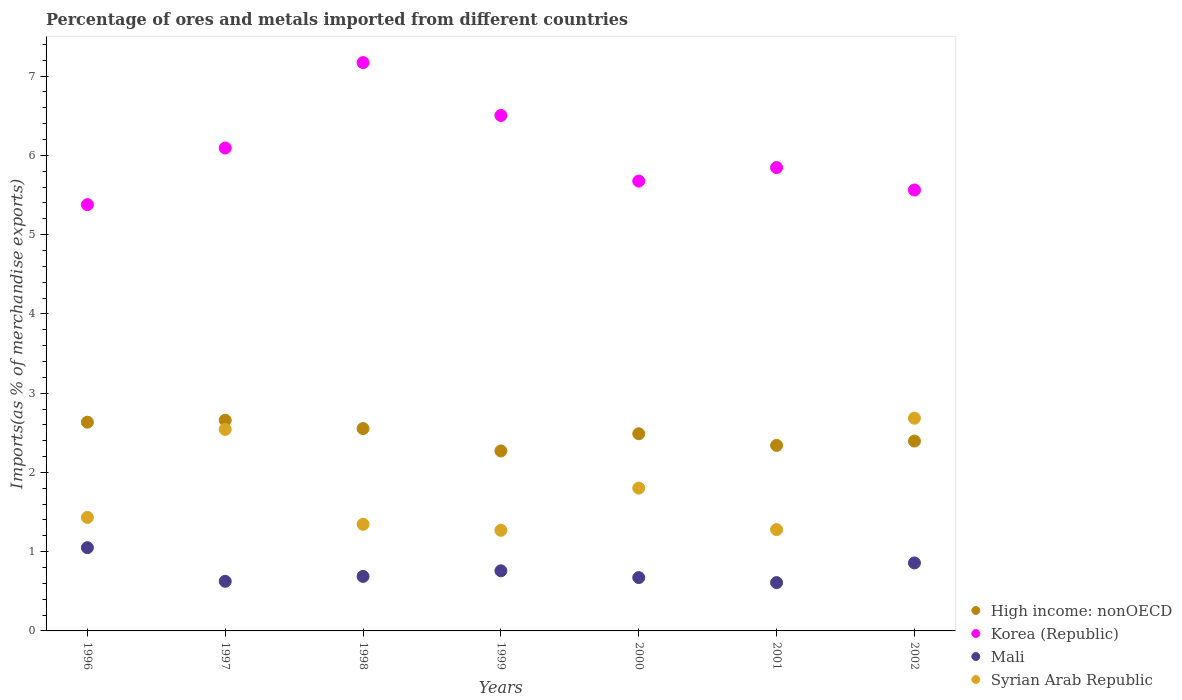How many different coloured dotlines are there?
Your answer should be compact. 4. Is the number of dotlines equal to the number of legend labels?
Make the answer very short. Yes. What is the percentage of imports to different countries in Mali in 2002?
Provide a short and direct response. 0.86. Across all years, what is the maximum percentage of imports to different countries in High income: nonOECD?
Offer a very short reply. 2.66. Across all years, what is the minimum percentage of imports to different countries in Syrian Arab Republic?
Make the answer very short. 1.27. What is the total percentage of imports to different countries in High income: nonOECD in the graph?
Ensure brevity in your answer.  17.34. What is the difference between the percentage of imports to different countries in High income: nonOECD in 2001 and that in 2002?
Provide a succinct answer. -0.05. What is the difference between the percentage of imports to different countries in Mali in 2002 and the percentage of imports to different countries in Korea (Republic) in 1996?
Offer a very short reply. -4.52. What is the average percentage of imports to different countries in Mali per year?
Keep it short and to the point. 0.75. In the year 2001, what is the difference between the percentage of imports to different countries in High income: nonOECD and percentage of imports to different countries in Mali?
Offer a very short reply. 1.73. What is the ratio of the percentage of imports to different countries in Korea (Republic) in 1998 to that in 2001?
Provide a succinct answer. 1.23. What is the difference between the highest and the second highest percentage of imports to different countries in Syrian Arab Republic?
Provide a short and direct response. 0.14. What is the difference between the highest and the lowest percentage of imports to different countries in Mali?
Your response must be concise. 0.44. Is the sum of the percentage of imports to different countries in High income: nonOECD in 1996 and 2002 greater than the maximum percentage of imports to different countries in Mali across all years?
Your response must be concise. Yes. Does the percentage of imports to different countries in Mali monotonically increase over the years?
Provide a succinct answer. No. Is the percentage of imports to different countries in Mali strictly less than the percentage of imports to different countries in Korea (Republic) over the years?
Offer a very short reply. Yes. How many dotlines are there?
Offer a terse response. 4. How many years are there in the graph?
Offer a very short reply. 7. Are the values on the major ticks of Y-axis written in scientific E-notation?
Your answer should be very brief. No. Does the graph contain grids?
Your response must be concise. No. Where does the legend appear in the graph?
Offer a very short reply. Bottom right. How many legend labels are there?
Provide a succinct answer. 4. What is the title of the graph?
Offer a very short reply. Percentage of ores and metals imported from different countries. Does "Tuvalu" appear as one of the legend labels in the graph?
Offer a very short reply. No. What is the label or title of the X-axis?
Provide a short and direct response. Years. What is the label or title of the Y-axis?
Your answer should be compact. Imports(as % of merchandise exports). What is the Imports(as % of merchandise exports) of High income: nonOECD in 1996?
Offer a terse response. 2.63. What is the Imports(as % of merchandise exports) in Korea (Republic) in 1996?
Offer a terse response. 5.38. What is the Imports(as % of merchandise exports) in Mali in 1996?
Ensure brevity in your answer.  1.05. What is the Imports(as % of merchandise exports) in Syrian Arab Republic in 1996?
Your response must be concise. 1.43. What is the Imports(as % of merchandise exports) in High income: nonOECD in 1997?
Make the answer very short. 2.66. What is the Imports(as % of merchandise exports) of Korea (Republic) in 1997?
Provide a short and direct response. 6.09. What is the Imports(as % of merchandise exports) of Mali in 1997?
Keep it short and to the point. 0.63. What is the Imports(as % of merchandise exports) in Syrian Arab Republic in 1997?
Your answer should be compact. 2.54. What is the Imports(as % of merchandise exports) in High income: nonOECD in 1998?
Your response must be concise. 2.55. What is the Imports(as % of merchandise exports) in Korea (Republic) in 1998?
Offer a terse response. 7.17. What is the Imports(as % of merchandise exports) of Mali in 1998?
Keep it short and to the point. 0.69. What is the Imports(as % of merchandise exports) in Syrian Arab Republic in 1998?
Offer a terse response. 1.35. What is the Imports(as % of merchandise exports) in High income: nonOECD in 1999?
Your answer should be very brief. 2.27. What is the Imports(as % of merchandise exports) of Korea (Republic) in 1999?
Make the answer very short. 6.5. What is the Imports(as % of merchandise exports) of Mali in 1999?
Offer a terse response. 0.76. What is the Imports(as % of merchandise exports) in Syrian Arab Republic in 1999?
Ensure brevity in your answer.  1.27. What is the Imports(as % of merchandise exports) of High income: nonOECD in 2000?
Give a very brief answer. 2.49. What is the Imports(as % of merchandise exports) of Korea (Republic) in 2000?
Provide a short and direct response. 5.68. What is the Imports(as % of merchandise exports) of Mali in 2000?
Keep it short and to the point. 0.67. What is the Imports(as % of merchandise exports) in Syrian Arab Republic in 2000?
Your answer should be compact. 1.8. What is the Imports(as % of merchandise exports) of High income: nonOECD in 2001?
Your answer should be compact. 2.34. What is the Imports(as % of merchandise exports) of Korea (Republic) in 2001?
Provide a short and direct response. 5.85. What is the Imports(as % of merchandise exports) in Mali in 2001?
Provide a short and direct response. 0.61. What is the Imports(as % of merchandise exports) in Syrian Arab Republic in 2001?
Your answer should be very brief. 1.28. What is the Imports(as % of merchandise exports) in High income: nonOECD in 2002?
Your answer should be compact. 2.4. What is the Imports(as % of merchandise exports) in Korea (Republic) in 2002?
Offer a very short reply. 5.56. What is the Imports(as % of merchandise exports) in Mali in 2002?
Make the answer very short. 0.86. What is the Imports(as % of merchandise exports) in Syrian Arab Republic in 2002?
Your response must be concise. 2.68. Across all years, what is the maximum Imports(as % of merchandise exports) in High income: nonOECD?
Keep it short and to the point. 2.66. Across all years, what is the maximum Imports(as % of merchandise exports) of Korea (Republic)?
Your answer should be compact. 7.17. Across all years, what is the maximum Imports(as % of merchandise exports) in Mali?
Your answer should be compact. 1.05. Across all years, what is the maximum Imports(as % of merchandise exports) in Syrian Arab Republic?
Your response must be concise. 2.68. Across all years, what is the minimum Imports(as % of merchandise exports) of High income: nonOECD?
Make the answer very short. 2.27. Across all years, what is the minimum Imports(as % of merchandise exports) in Korea (Republic)?
Offer a very short reply. 5.38. Across all years, what is the minimum Imports(as % of merchandise exports) in Mali?
Your answer should be compact. 0.61. Across all years, what is the minimum Imports(as % of merchandise exports) of Syrian Arab Republic?
Your answer should be very brief. 1.27. What is the total Imports(as % of merchandise exports) of High income: nonOECD in the graph?
Your answer should be compact. 17.34. What is the total Imports(as % of merchandise exports) of Korea (Republic) in the graph?
Offer a very short reply. 42.23. What is the total Imports(as % of merchandise exports) of Mali in the graph?
Your response must be concise. 5.26. What is the total Imports(as % of merchandise exports) of Syrian Arab Republic in the graph?
Make the answer very short. 12.35. What is the difference between the Imports(as % of merchandise exports) in High income: nonOECD in 1996 and that in 1997?
Your response must be concise. -0.02. What is the difference between the Imports(as % of merchandise exports) in Korea (Republic) in 1996 and that in 1997?
Keep it short and to the point. -0.71. What is the difference between the Imports(as % of merchandise exports) in Mali in 1996 and that in 1997?
Offer a terse response. 0.42. What is the difference between the Imports(as % of merchandise exports) of Syrian Arab Republic in 1996 and that in 1997?
Ensure brevity in your answer.  -1.11. What is the difference between the Imports(as % of merchandise exports) in High income: nonOECD in 1996 and that in 1998?
Offer a very short reply. 0.08. What is the difference between the Imports(as % of merchandise exports) in Korea (Republic) in 1996 and that in 1998?
Your response must be concise. -1.79. What is the difference between the Imports(as % of merchandise exports) of Mali in 1996 and that in 1998?
Keep it short and to the point. 0.36. What is the difference between the Imports(as % of merchandise exports) in Syrian Arab Republic in 1996 and that in 1998?
Provide a succinct answer. 0.09. What is the difference between the Imports(as % of merchandise exports) of High income: nonOECD in 1996 and that in 1999?
Offer a terse response. 0.36. What is the difference between the Imports(as % of merchandise exports) in Korea (Republic) in 1996 and that in 1999?
Keep it short and to the point. -1.13. What is the difference between the Imports(as % of merchandise exports) of Mali in 1996 and that in 1999?
Ensure brevity in your answer.  0.29. What is the difference between the Imports(as % of merchandise exports) in Syrian Arab Republic in 1996 and that in 1999?
Keep it short and to the point. 0.16. What is the difference between the Imports(as % of merchandise exports) of High income: nonOECD in 1996 and that in 2000?
Offer a terse response. 0.15. What is the difference between the Imports(as % of merchandise exports) in Korea (Republic) in 1996 and that in 2000?
Make the answer very short. -0.3. What is the difference between the Imports(as % of merchandise exports) of Mali in 1996 and that in 2000?
Offer a terse response. 0.38. What is the difference between the Imports(as % of merchandise exports) in Syrian Arab Republic in 1996 and that in 2000?
Make the answer very short. -0.37. What is the difference between the Imports(as % of merchandise exports) of High income: nonOECD in 1996 and that in 2001?
Your answer should be very brief. 0.29. What is the difference between the Imports(as % of merchandise exports) in Korea (Republic) in 1996 and that in 2001?
Your answer should be very brief. -0.47. What is the difference between the Imports(as % of merchandise exports) of Mali in 1996 and that in 2001?
Your response must be concise. 0.44. What is the difference between the Imports(as % of merchandise exports) in Syrian Arab Republic in 1996 and that in 2001?
Keep it short and to the point. 0.15. What is the difference between the Imports(as % of merchandise exports) of High income: nonOECD in 1996 and that in 2002?
Your answer should be compact. 0.24. What is the difference between the Imports(as % of merchandise exports) of Korea (Republic) in 1996 and that in 2002?
Ensure brevity in your answer.  -0.18. What is the difference between the Imports(as % of merchandise exports) of Mali in 1996 and that in 2002?
Ensure brevity in your answer.  0.19. What is the difference between the Imports(as % of merchandise exports) of Syrian Arab Republic in 1996 and that in 2002?
Make the answer very short. -1.25. What is the difference between the Imports(as % of merchandise exports) of High income: nonOECD in 1997 and that in 1998?
Your answer should be compact. 0.1. What is the difference between the Imports(as % of merchandise exports) in Korea (Republic) in 1997 and that in 1998?
Your answer should be very brief. -1.08. What is the difference between the Imports(as % of merchandise exports) of Mali in 1997 and that in 1998?
Your response must be concise. -0.06. What is the difference between the Imports(as % of merchandise exports) of Syrian Arab Republic in 1997 and that in 1998?
Offer a terse response. 1.2. What is the difference between the Imports(as % of merchandise exports) of High income: nonOECD in 1997 and that in 1999?
Your response must be concise. 0.39. What is the difference between the Imports(as % of merchandise exports) of Korea (Republic) in 1997 and that in 1999?
Keep it short and to the point. -0.41. What is the difference between the Imports(as % of merchandise exports) of Mali in 1997 and that in 1999?
Offer a very short reply. -0.13. What is the difference between the Imports(as % of merchandise exports) in Syrian Arab Republic in 1997 and that in 1999?
Offer a terse response. 1.27. What is the difference between the Imports(as % of merchandise exports) in High income: nonOECD in 1997 and that in 2000?
Provide a succinct answer. 0.17. What is the difference between the Imports(as % of merchandise exports) in Korea (Republic) in 1997 and that in 2000?
Offer a terse response. 0.42. What is the difference between the Imports(as % of merchandise exports) of Mali in 1997 and that in 2000?
Offer a very short reply. -0.05. What is the difference between the Imports(as % of merchandise exports) of Syrian Arab Republic in 1997 and that in 2000?
Provide a short and direct response. 0.74. What is the difference between the Imports(as % of merchandise exports) of High income: nonOECD in 1997 and that in 2001?
Offer a very short reply. 0.32. What is the difference between the Imports(as % of merchandise exports) in Korea (Republic) in 1997 and that in 2001?
Ensure brevity in your answer.  0.25. What is the difference between the Imports(as % of merchandise exports) in Mali in 1997 and that in 2001?
Your answer should be very brief. 0.02. What is the difference between the Imports(as % of merchandise exports) of Syrian Arab Republic in 1997 and that in 2001?
Make the answer very short. 1.26. What is the difference between the Imports(as % of merchandise exports) of High income: nonOECD in 1997 and that in 2002?
Keep it short and to the point. 0.26. What is the difference between the Imports(as % of merchandise exports) in Korea (Republic) in 1997 and that in 2002?
Provide a succinct answer. 0.53. What is the difference between the Imports(as % of merchandise exports) of Mali in 1997 and that in 2002?
Provide a succinct answer. -0.23. What is the difference between the Imports(as % of merchandise exports) of Syrian Arab Republic in 1997 and that in 2002?
Keep it short and to the point. -0.14. What is the difference between the Imports(as % of merchandise exports) of High income: nonOECD in 1998 and that in 1999?
Make the answer very short. 0.28. What is the difference between the Imports(as % of merchandise exports) of Korea (Republic) in 1998 and that in 1999?
Give a very brief answer. 0.67. What is the difference between the Imports(as % of merchandise exports) of Mali in 1998 and that in 1999?
Ensure brevity in your answer.  -0.07. What is the difference between the Imports(as % of merchandise exports) in Syrian Arab Republic in 1998 and that in 1999?
Keep it short and to the point. 0.08. What is the difference between the Imports(as % of merchandise exports) in High income: nonOECD in 1998 and that in 2000?
Your answer should be compact. 0.07. What is the difference between the Imports(as % of merchandise exports) of Korea (Republic) in 1998 and that in 2000?
Offer a very short reply. 1.5. What is the difference between the Imports(as % of merchandise exports) in Mali in 1998 and that in 2000?
Offer a very short reply. 0.01. What is the difference between the Imports(as % of merchandise exports) of Syrian Arab Republic in 1998 and that in 2000?
Provide a short and direct response. -0.46. What is the difference between the Imports(as % of merchandise exports) of High income: nonOECD in 1998 and that in 2001?
Make the answer very short. 0.21. What is the difference between the Imports(as % of merchandise exports) of Korea (Republic) in 1998 and that in 2001?
Keep it short and to the point. 1.32. What is the difference between the Imports(as % of merchandise exports) in Mali in 1998 and that in 2001?
Offer a terse response. 0.08. What is the difference between the Imports(as % of merchandise exports) of Syrian Arab Republic in 1998 and that in 2001?
Provide a short and direct response. 0.07. What is the difference between the Imports(as % of merchandise exports) in High income: nonOECD in 1998 and that in 2002?
Keep it short and to the point. 0.16. What is the difference between the Imports(as % of merchandise exports) in Korea (Republic) in 1998 and that in 2002?
Your answer should be compact. 1.61. What is the difference between the Imports(as % of merchandise exports) of Mali in 1998 and that in 2002?
Give a very brief answer. -0.17. What is the difference between the Imports(as % of merchandise exports) in Syrian Arab Republic in 1998 and that in 2002?
Provide a succinct answer. -1.34. What is the difference between the Imports(as % of merchandise exports) of High income: nonOECD in 1999 and that in 2000?
Keep it short and to the point. -0.22. What is the difference between the Imports(as % of merchandise exports) of Korea (Republic) in 1999 and that in 2000?
Make the answer very short. 0.83. What is the difference between the Imports(as % of merchandise exports) of Mali in 1999 and that in 2000?
Your answer should be compact. 0.09. What is the difference between the Imports(as % of merchandise exports) in Syrian Arab Republic in 1999 and that in 2000?
Ensure brevity in your answer.  -0.53. What is the difference between the Imports(as % of merchandise exports) of High income: nonOECD in 1999 and that in 2001?
Your response must be concise. -0.07. What is the difference between the Imports(as % of merchandise exports) of Korea (Republic) in 1999 and that in 2001?
Your answer should be compact. 0.66. What is the difference between the Imports(as % of merchandise exports) of Mali in 1999 and that in 2001?
Your answer should be very brief. 0.15. What is the difference between the Imports(as % of merchandise exports) of Syrian Arab Republic in 1999 and that in 2001?
Give a very brief answer. -0.01. What is the difference between the Imports(as % of merchandise exports) of High income: nonOECD in 1999 and that in 2002?
Make the answer very short. -0.12. What is the difference between the Imports(as % of merchandise exports) of Korea (Republic) in 1999 and that in 2002?
Provide a short and direct response. 0.94. What is the difference between the Imports(as % of merchandise exports) of Mali in 1999 and that in 2002?
Provide a short and direct response. -0.1. What is the difference between the Imports(as % of merchandise exports) of Syrian Arab Republic in 1999 and that in 2002?
Provide a short and direct response. -1.41. What is the difference between the Imports(as % of merchandise exports) in High income: nonOECD in 2000 and that in 2001?
Provide a succinct answer. 0.15. What is the difference between the Imports(as % of merchandise exports) in Korea (Republic) in 2000 and that in 2001?
Ensure brevity in your answer.  -0.17. What is the difference between the Imports(as % of merchandise exports) of Mali in 2000 and that in 2001?
Your response must be concise. 0.06. What is the difference between the Imports(as % of merchandise exports) of Syrian Arab Republic in 2000 and that in 2001?
Offer a very short reply. 0.52. What is the difference between the Imports(as % of merchandise exports) of High income: nonOECD in 2000 and that in 2002?
Provide a succinct answer. 0.09. What is the difference between the Imports(as % of merchandise exports) in Korea (Republic) in 2000 and that in 2002?
Offer a very short reply. 0.11. What is the difference between the Imports(as % of merchandise exports) in Mali in 2000 and that in 2002?
Your answer should be compact. -0.18. What is the difference between the Imports(as % of merchandise exports) of Syrian Arab Republic in 2000 and that in 2002?
Your answer should be very brief. -0.88. What is the difference between the Imports(as % of merchandise exports) in High income: nonOECD in 2001 and that in 2002?
Give a very brief answer. -0.05. What is the difference between the Imports(as % of merchandise exports) in Korea (Republic) in 2001 and that in 2002?
Make the answer very short. 0.28. What is the difference between the Imports(as % of merchandise exports) of Mali in 2001 and that in 2002?
Provide a short and direct response. -0.25. What is the difference between the Imports(as % of merchandise exports) of Syrian Arab Republic in 2001 and that in 2002?
Ensure brevity in your answer.  -1.41. What is the difference between the Imports(as % of merchandise exports) of High income: nonOECD in 1996 and the Imports(as % of merchandise exports) of Korea (Republic) in 1997?
Ensure brevity in your answer.  -3.46. What is the difference between the Imports(as % of merchandise exports) in High income: nonOECD in 1996 and the Imports(as % of merchandise exports) in Mali in 1997?
Your response must be concise. 2.01. What is the difference between the Imports(as % of merchandise exports) of High income: nonOECD in 1996 and the Imports(as % of merchandise exports) of Syrian Arab Republic in 1997?
Your answer should be very brief. 0.09. What is the difference between the Imports(as % of merchandise exports) of Korea (Republic) in 1996 and the Imports(as % of merchandise exports) of Mali in 1997?
Give a very brief answer. 4.75. What is the difference between the Imports(as % of merchandise exports) of Korea (Republic) in 1996 and the Imports(as % of merchandise exports) of Syrian Arab Republic in 1997?
Make the answer very short. 2.84. What is the difference between the Imports(as % of merchandise exports) in Mali in 1996 and the Imports(as % of merchandise exports) in Syrian Arab Republic in 1997?
Make the answer very short. -1.49. What is the difference between the Imports(as % of merchandise exports) in High income: nonOECD in 1996 and the Imports(as % of merchandise exports) in Korea (Republic) in 1998?
Your response must be concise. -4.54. What is the difference between the Imports(as % of merchandise exports) of High income: nonOECD in 1996 and the Imports(as % of merchandise exports) of Mali in 1998?
Give a very brief answer. 1.95. What is the difference between the Imports(as % of merchandise exports) of High income: nonOECD in 1996 and the Imports(as % of merchandise exports) of Syrian Arab Republic in 1998?
Offer a very short reply. 1.29. What is the difference between the Imports(as % of merchandise exports) of Korea (Republic) in 1996 and the Imports(as % of merchandise exports) of Mali in 1998?
Provide a succinct answer. 4.69. What is the difference between the Imports(as % of merchandise exports) in Korea (Republic) in 1996 and the Imports(as % of merchandise exports) in Syrian Arab Republic in 1998?
Offer a terse response. 4.03. What is the difference between the Imports(as % of merchandise exports) in Mali in 1996 and the Imports(as % of merchandise exports) in Syrian Arab Republic in 1998?
Offer a terse response. -0.29. What is the difference between the Imports(as % of merchandise exports) in High income: nonOECD in 1996 and the Imports(as % of merchandise exports) in Korea (Republic) in 1999?
Offer a terse response. -3.87. What is the difference between the Imports(as % of merchandise exports) in High income: nonOECD in 1996 and the Imports(as % of merchandise exports) in Mali in 1999?
Your response must be concise. 1.88. What is the difference between the Imports(as % of merchandise exports) of High income: nonOECD in 1996 and the Imports(as % of merchandise exports) of Syrian Arab Republic in 1999?
Provide a succinct answer. 1.36. What is the difference between the Imports(as % of merchandise exports) of Korea (Republic) in 1996 and the Imports(as % of merchandise exports) of Mali in 1999?
Provide a succinct answer. 4.62. What is the difference between the Imports(as % of merchandise exports) of Korea (Republic) in 1996 and the Imports(as % of merchandise exports) of Syrian Arab Republic in 1999?
Ensure brevity in your answer.  4.11. What is the difference between the Imports(as % of merchandise exports) of Mali in 1996 and the Imports(as % of merchandise exports) of Syrian Arab Republic in 1999?
Your response must be concise. -0.22. What is the difference between the Imports(as % of merchandise exports) of High income: nonOECD in 1996 and the Imports(as % of merchandise exports) of Korea (Republic) in 2000?
Provide a succinct answer. -3.04. What is the difference between the Imports(as % of merchandise exports) of High income: nonOECD in 1996 and the Imports(as % of merchandise exports) of Mali in 2000?
Your response must be concise. 1.96. What is the difference between the Imports(as % of merchandise exports) in High income: nonOECD in 1996 and the Imports(as % of merchandise exports) in Syrian Arab Republic in 2000?
Your answer should be very brief. 0.83. What is the difference between the Imports(as % of merchandise exports) of Korea (Republic) in 1996 and the Imports(as % of merchandise exports) of Mali in 2000?
Make the answer very short. 4.71. What is the difference between the Imports(as % of merchandise exports) in Korea (Republic) in 1996 and the Imports(as % of merchandise exports) in Syrian Arab Republic in 2000?
Ensure brevity in your answer.  3.58. What is the difference between the Imports(as % of merchandise exports) in Mali in 1996 and the Imports(as % of merchandise exports) in Syrian Arab Republic in 2000?
Make the answer very short. -0.75. What is the difference between the Imports(as % of merchandise exports) in High income: nonOECD in 1996 and the Imports(as % of merchandise exports) in Korea (Republic) in 2001?
Keep it short and to the point. -3.21. What is the difference between the Imports(as % of merchandise exports) in High income: nonOECD in 1996 and the Imports(as % of merchandise exports) in Mali in 2001?
Offer a very short reply. 2.02. What is the difference between the Imports(as % of merchandise exports) in High income: nonOECD in 1996 and the Imports(as % of merchandise exports) in Syrian Arab Republic in 2001?
Keep it short and to the point. 1.35. What is the difference between the Imports(as % of merchandise exports) in Korea (Republic) in 1996 and the Imports(as % of merchandise exports) in Mali in 2001?
Give a very brief answer. 4.77. What is the difference between the Imports(as % of merchandise exports) of Korea (Republic) in 1996 and the Imports(as % of merchandise exports) of Syrian Arab Republic in 2001?
Offer a terse response. 4.1. What is the difference between the Imports(as % of merchandise exports) in Mali in 1996 and the Imports(as % of merchandise exports) in Syrian Arab Republic in 2001?
Provide a succinct answer. -0.23. What is the difference between the Imports(as % of merchandise exports) of High income: nonOECD in 1996 and the Imports(as % of merchandise exports) of Korea (Republic) in 2002?
Offer a very short reply. -2.93. What is the difference between the Imports(as % of merchandise exports) of High income: nonOECD in 1996 and the Imports(as % of merchandise exports) of Mali in 2002?
Offer a terse response. 1.78. What is the difference between the Imports(as % of merchandise exports) in High income: nonOECD in 1996 and the Imports(as % of merchandise exports) in Syrian Arab Republic in 2002?
Keep it short and to the point. -0.05. What is the difference between the Imports(as % of merchandise exports) of Korea (Republic) in 1996 and the Imports(as % of merchandise exports) of Mali in 2002?
Provide a short and direct response. 4.52. What is the difference between the Imports(as % of merchandise exports) in Korea (Republic) in 1996 and the Imports(as % of merchandise exports) in Syrian Arab Republic in 2002?
Give a very brief answer. 2.69. What is the difference between the Imports(as % of merchandise exports) of Mali in 1996 and the Imports(as % of merchandise exports) of Syrian Arab Republic in 2002?
Keep it short and to the point. -1.63. What is the difference between the Imports(as % of merchandise exports) of High income: nonOECD in 1997 and the Imports(as % of merchandise exports) of Korea (Republic) in 1998?
Provide a succinct answer. -4.51. What is the difference between the Imports(as % of merchandise exports) of High income: nonOECD in 1997 and the Imports(as % of merchandise exports) of Mali in 1998?
Your response must be concise. 1.97. What is the difference between the Imports(as % of merchandise exports) in High income: nonOECD in 1997 and the Imports(as % of merchandise exports) in Syrian Arab Republic in 1998?
Your answer should be very brief. 1.31. What is the difference between the Imports(as % of merchandise exports) of Korea (Republic) in 1997 and the Imports(as % of merchandise exports) of Mali in 1998?
Provide a short and direct response. 5.4. What is the difference between the Imports(as % of merchandise exports) of Korea (Republic) in 1997 and the Imports(as % of merchandise exports) of Syrian Arab Republic in 1998?
Ensure brevity in your answer.  4.75. What is the difference between the Imports(as % of merchandise exports) in Mali in 1997 and the Imports(as % of merchandise exports) in Syrian Arab Republic in 1998?
Provide a succinct answer. -0.72. What is the difference between the Imports(as % of merchandise exports) in High income: nonOECD in 1997 and the Imports(as % of merchandise exports) in Korea (Republic) in 1999?
Keep it short and to the point. -3.85. What is the difference between the Imports(as % of merchandise exports) of High income: nonOECD in 1997 and the Imports(as % of merchandise exports) of Mali in 1999?
Provide a succinct answer. 1.9. What is the difference between the Imports(as % of merchandise exports) in High income: nonOECD in 1997 and the Imports(as % of merchandise exports) in Syrian Arab Republic in 1999?
Your response must be concise. 1.39. What is the difference between the Imports(as % of merchandise exports) of Korea (Republic) in 1997 and the Imports(as % of merchandise exports) of Mali in 1999?
Give a very brief answer. 5.33. What is the difference between the Imports(as % of merchandise exports) in Korea (Republic) in 1997 and the Imports(as % of merchandise exports) in Syrian Arab Republic in 1999?
Offer a very short reply. 4.82. What is the difference between the Imports(as % of merchandise exports) of Mali in 1997 and the Imports(as % of merchandise exports) of Syrian Arab Republic in 1999?
Offer a very short reply. -0.64. What is the difference between the Imports(as % of merchandise exports) of High income: nonOECD in 1997 and the Imports(as % of merchandise exports) of Korea (Republic) in 2000?
Make the answer very short. -3.02. What is the difference between the Imports(as % of merchandise exports) in High income: nonOECD in 1997 and the Imports(as % of merchandise exports) in Mali in 2000?
Your answer should be compact. 1.99. What is the difference between the Imports(as % of merchandise exports) of High income: nonOECD in 1997 and the Imports(as % of merchandise exports) of Syrian Arab Republic in 2000?
Ensure brevity in your answer.  0.86. What is the difference between the Imports(as % of merchandise exports) in Korea (Republic) in 1997 and the Imports(as % of merchandise exports) in Mali in 2000?
Offer a very short reply. 5.42. What is the difference between the Imports(as % of merchandise exports) of Korea (Republic) in 1997 and the Imports(as % of merchandise exports) of Syrian Arab Republic in 2000?
Provide a short and direct response. 4.29. What is the difference between the Imports(as % of merchandise exports) in Mali in 1997 and the Imports(as % of merchandise exports) in Syrian Arab Republic in 2000?
Provide a succinct answer. -1.18. What is the difference between the Imports(as % of merchandise exports) of High income: nonOECD in 1997 and the Imports(as % of merchandise exports) of Korea (Republic) in 2001?
Your response must be concise. -3.19. What is the difference between the Imports(as % of merchandise exports) of High income: nonOECD in 1997 and the Imports(as % of merchandise exports) of Mali in 2001?
Your answer should be compact. 2.05. What is the difference between the Imports(as % of merchandise exports) in High income: nonOECD in 1997 and the Imports(as % of merchandise exports) in Syrian Arab Republic in 2001?
Keep it short and to the point. 1.38. What is the difference between the Imports(as % of merchandise exports) of Korea (Republic) in 1997 and the Imports(as % of merchandise exports) of Mali in 2001?
Keep it short and to the point. 5.48. What is the difference between the Imports(as % of merchandise exports) of Korea (Republic) in 1997 and the Imports(as % of merchandise exports) of Syrian Arab Republic in 2001?
Make the answer very short. 4.81. What is the difference between the Imports(as % of merchandise exports) in Mali in 1997 and the Imports(as % of merchandise exports) in Syrian Arab Republic in 2001?
Provide a succinct answer. -0.65. What is the difference between the Imports(as % of merchandise exports) in High income: nonOECD in 1997 and the Imports(as % of merchandise exports) in Korea (Republic) in 2002?
Make the answer very short. -2.9. What is the difference between the Imports(as % of merchandise exports) in High income: nonOECD in 1997 and the Imports(as % of merchandise exports) in Mali in 2002?
Give a very brief answer. 1.8. What is the difference between the Imports(as % of merchandise exports) in High income: nonOECD in 1997 and the Imports(as % of merchandise exports) in Syrian Arab Republic in 2002?
Offer a very short reply. -0.03. What is the difference between the Imports(as % of merchandise exports) in Korea (Republic) in 1997 and the Imports(as % of merchandise exports) in Mali in 2002?
Give a very brief answer. 5.23. What is the difference between the Imports(as % of merchandise exports) of Korea (Republic) in 1997 and the Imports(as % of merchandise exports) of Syrian Arab Republic in 2002?
Offer a very short reply. 3.41. What is the difference between the Imports(as % of merchandise exports) in Mali in 1997 and the Imports(as % of merchandise exports) in Syrian Arab Republic in 2002?
Keep it short and to the point. -2.06. What is the difference between the Imports(as % of merchandise exports) in High income: nonOECD in 1998 and the Imports(as % of merchandise exports) in Korea (Republic) in 1999?
Offer a very short reply. -3.95. What is the difference between the Imports(as % of merchandise exports) in High income: nonOECD in 1998 and the Imports(as % of merchandise exports) in Mali in 1999?
Make the answer very short. 1.79. What is the difference between the Imports(as % of merchandise exports) in High income: nonOECD in 1998 and the Imports(as % of merchandise exports) in Syrian Arab Republic in 1999?
Your answer should be compact. 1.28. What is the difference between the Imports(as % of merchandise exports) of Korea (Republic) in 1998 and the Imports(as % of merchandise exports) of Mali in 1999?
Keep it short and to the point. 6.41. What is the difference between the Imports(as % of merchandise exports) of Korea (Republic) in 1998 and the Imports(as % of merchandise exports) of Syrian Arab Republic in 1999?
Your answer should be very brief. 5.9. What is the difference between the Imports(as % of merchandise exports) of Mali in 1998 and the Imports(as % of merchandise exports) of Syrian Arab Republic in 1999?
Make the answer very short. -0.58. What is the difference between the Imports(as % of merchandise exports) of High income: nonOECD in 1998 and the Imports(as % of merchandise exports) of Korea (Republic) in 2000?
Ensure brevity in your answer.  -3.12. What is the difference between the Imports(as % of merchandise exports) of High income: nonOECD in 1998 and the Imports(as % of merchandise exports) of Mali in 2000?
Your answer should be very brief. 1.88. What is the difference between the Imports(as % of merchandise exports) in High income: nonOECD in 1998 and the Imports(as % of merchandise exports) in Syrian Arab Republic in 2000?
Give a very brief answer. 0.75. What is the difference between the Imports(as % of merchandise exports) in Korea (Republic) in 1998 and the Imports(as % of merchandise exports) in Mali in 2000?
Offer a very short reply. 6.5. What is the difference between the Imports(as % of merchandise exports) in Korea (Republic) in 1998 and the Imports(as % of merchandise exports) in Syrian Arab Republic in 2000?
Your answer should be compact. 5.37. What is the difference between the Imports(as % of merchandise exports) of Mali in 1998 and the Imports(as % of merchandise exports) of Syrian Arab Republic in 2000?
Your answer should be very brief. -1.11. What is the difference between the Imports(as % of merchandise exports) of High income: nonOECD in 1998 and the Imports(as % of merchandise exports) of Korea (Republic) in 2001?
Your answer should be compact. -3.29. What is the difference between the Imports(as % of merchandise exports) of High income: nonOECD in 1998 and the Imports(as % of merchandise exports) of Mali in 2001?
Give a very brief answer. 1.94. What is the difference between the Imports(as % of merchandise exports) of High income: nonOECD in 1998 and the Imports(as % of merchandise exports) of Syrian Arab Republic in 2001?
Your answer should be compact. 1.27. What is the difference between the Imports(as % of merchandise exports) of Korea (Republic) in 1998 and the Imports(as % of merchandise exports) of Mali in 2001?
Ensure brevity in your answer.  6.56. What is the difference between the Imports(as % of merchandise exports) of Korea (Republic) in 1998 and the Imports(as % of merchandise exports) of Syrian Arab Republic in 2001?
Offer a very short reply. 5.89. What is the difference between the Imports(as % of merchandise exports) of Mali in 1998 and the Imports(as % of merchandise exports) of Syrian Arab Republic in 2001?
Offer a very short reply. -0.59. What is the difference between the Imports(as % of merchandise exports) in High income: nonOECD in 1998 and the Imports(as % of merchandise exports) in Korea (Republic) in 2002?
Your answer should be compact. -3.01. What is the difference between the Imports(as % of merchandise exports) in High income: nonOECD in 1998 and the Imports(as % of merchandise exports) in Mali in 2002?
Provide a short and direct response. 1.7. What is the difference between the Imports(as % of merchandise exports) of High income: nonOECD in 1998 and the Imports(as % of merchandise exports) of Syrian Arab Republic in 2002?
Your response must be concise. -0.13. What is the difference between the Imports(as % of merchandise exports) of Korea (Republic) in 1998 and the Imports(as % of merchandise exports) of Mali in 2002?
Ensure brevity in your answer.  6.31. What is the difference between the Imports(as % of merchandise exports) in Korea (Republic) in 1998 and the Imports(as % of merchandise exports) in Syrian Arab Republic in 2002?
Your answer should be compact. 4.49. What is the difference between the Imports(as % of merchandise exports) of Mali in 1998 and the Imports(as % of merchandise exports) of Syrian Arab Republic in 2002?
Ensure brevity in your answer.  -2. What is the difference between the Imports(as % of merchandise exports) of High income: nonOECD in 1999 and the Imports(as % of merchandise exports) of Korea (Republic) in 2000?
Keep it short and to the point. -3.41. What is the difference between the Imports(as % of merchandise exports) of High income: nonOECD in 1999 and the Imports(as % of merchandise exports) of Mali in 2000?
Give a very brief answer. 1.6. What is the difference between the Imports(as % of merchandise exports) of High income: nonOECD in 1999 and the Imports(as % of merchandise exports) of Syrian Arab Republic in 2000?
Provide a short and direct response. 0.47. What is the difference between the Imports(as % of merchandise exports) of Korea (Republic) in 1999 and the Imports(as % of merchandise exports) of Mali in 2000?
Your answer should be very brief. 5.83. What is the difference between the Imports(as % of merchandise exports) of Korea (Republic) in 1999 and the Imports(as % of merchandise exports) of Syrian Arab Republic in 2000?
Your response must be concise. 4.7. What is the difference between the Imports(as % of merchandise exports) of Mali in 1999 and the Imports(as % of merchandise exports) of Syrian Arab Republic in 2000?
Give a very brief answer. -1.04. What is the difference between the Imports(as % of merchandise exports) in High income: nonOECD in 1999 and the Imports(as % of merchandise exports) in Korea (Republic) in 2001?
Make the answer very short. -3.58. What is the difference between the Imports(as % of merchandise exports) in High income: nonOECD in 1999 and the Imports(as % of merchandise exports) in Mali in 2001?
Your answer should be compact. 1.66. What is the difference between the Imports(as % of merchandise exports) of High income: nonOECD in 1999 and the Imports(as % of merchandise exports) of Syrian Arab Republic in 2001?
Your answer should be very brief. 0.99. What is the difference between the Imports(as % of merchandise exports) of Korea (Republic) in 1999 and the Imports(as % of merchandise exports) of Mali in 2001?
Provide a short and direct response. 5.89. What is the difference between the Imports(as % of merchandise exports) of Korea (Republic) in 1999 and the Imports(as % of merchandise exports) of Syrian Arab Republic in 2001?
Keep it short and to the point. 5.22. What is the difference between the Imports(as % of merchandise exports) in Mali in 1999 and the Imports(as % of merchandise exports) in Syrian Arab Republic in 2001?
Ensure brevity in your answer.  -0.52. What is the difference between the Imports(as % of merchandise exports) of High income: nonOECD in 1999 and the Imports(as % of merchandise exports) of Korea (Republic) in 2002?
Give a very brief answer. -3.29. What is the difference between the Imports(as % of merchandise exports) in High income: nonOECD in 1999 and the Imports(as % of merchandise exports) in Mali in 2002?
Offer a very short reply. 1.41. What is the difference between the Imports(as % of merchandise exports) in High income: nonOECD in 1999 and the Imports(as % of merchandise exports) in Syrian Arab Republic in 2002?
Your answer should be compact. -0.41. What is the difference between the Imports(as % of merchandise exports) of Korea (Republic) in 1999 and the Imports(as % of merchandise exports) of Mali in 2002?
Your answer should be compact. 5.65. What is the difference between the Imports(as % of merchandise exports) in Korea (Republic) in 1999 and the Imports(as % of merchandise exports) in Syrian Arab Republic in 2002?
Offer a terse response. 3.82. What is the difference between the Imports(as % of merchandise exports) in Mali in 1999 and the Imports(as % of merchandise exports) in Syrian Arab Republic in 2002?
Your answer should be compact. -1.93. What is the difference between the Imports(as % of merchandise exports) in High income: nonOECD in 2000 and the Imports(as % of merchandise exports) in Korea (Republic) in 2001?
Your answer should be compact. -3.36. What is the difference between the Imports(as % of merchandise exports) of High income: nonOECD in 2000 and the Imports(as % of merchandise exports) of Mali in 2001?
Provide a short and direct response. 1.88. What is the difference between the Imports(as % of merchandise exports) of High income: nonOECD in 2000 and the Imports(as % of merchandise exports) of Syrian Arab Republic in 2001?
Your response must be concise. 1.21. What is the difference between the Imports(as % of merchandise exports) in Korea (Republic) in 2000 and the Imports(as % of merchandise exports) in Mali in 2001?
Keep it short and to the point. 5.07. What is the difference between the Imports(as % of merchandise exports) of Korea (Republic) in 2000 and the Imports(as % of merchandise exports) of Syrian Arab Republic in 2001?
Provide a short and direct response. 4.4. What is the difference between the Imports(as % of merchandise exports) of Mali in 2000 and the Imports(as % of merchandise exports) of Syrian Arab Republic in 2001?
Keep it short and to the point. -0.61. What is the difference between the Imports(as % of merchandise exports) of High income: nonOECD in 2000 and the Imports(as % of merchandise exports) of Korea (Republic) in 2002?
Make the answer very short. -3.08. What is the difference between the Imports(as % of merchandise exports) of High income: nonOECD in 2000 and the Imports(as % of merchandise exports) of Mali in 2002?
Provide a succinct answer. 1.63. What is the difference between the Imports(as % of merchandise exports) in High income: nonOECD in 2000 and the Imports(as % of merchandise exports) in Syrian Arab Republic in 2002?
Offer a terse response. -0.2. What is the difference between the Imports(as % of merchandise exports) in Korea (Republic) in 2000 and the Imports(as % of merchandise exports) in Mali in 2002?
Provide a succinct answer. 4.82. What is the difference between the Imports(as % of merchandise exports) of Korea (Republic) in 2000 and the Imports(as % of merchandise exports) of Syrian Arab Republic in 2002?
Keep it short and to the point. 2.99. What is the difference between the Imports(as % of merchandise exports) of Mali in 2000 and the Imports(as % of merchandise exports) of Syrian Arab Republic in 2002?
Your response must be concise. -2.01. What is the difference between the Imports(as % of merchandise exports) in High income: nonOECD in 2001 and the Imports(as % of merchandise exports) in Korea (Republic) in 2002?
Offer a very short reply. -3.22. What is the difference between the Imports(as % of merchandise exports) in High income: nonOECD in 2001 and the Imports(as % of merchandise exports) in Mali in 2002?
Provide a succinct answer. 1.48. What is the difference between the Imports(as % of merchandise exports) in High income: nonOECD in 2001 and the Imports(as % of merchandise exports) in Syrian Arab Republic in 2002?
Your answer should be compact. -0.34. What is the difference between the Imports(as % of merchandise exports) in Korea (Republic) in 2001 and the Imports(as % of merchandise exports) in Mali in 2002?
Give a very brief answer. 4.99. What is the difference between the Imports(as % of merchandise exports) of Korea (Republic) in 2001 and the Imports(as % of merchandise exports) of Syrian Arab Republic in 2002?
Your response must be concise. 3.16. What is the difference between the Imports(as % of merchandise exports) in Mali in 2001 and the Imports(as % of merchandise exports) in Syrian Arab Republic in 2002?
Offer a very short reply. -2.07. What is the average Imports(as % of merchandise exports) in High income: nonOECD per year?
Provide a succinct answer. 2.48. What is the average Imports(as % of merchandise exports) in Korea (Republic) per year?
Ensure brevity in your answer.  6.03. What is the average Imports(as % of merchandise exports) in Mali per year?
Make the answer very short. 0.75. What is the average Imports(as % of merchandise exports) of Syrian Arab Republic per year?
Make the answer very short. 1.76. In the year 1996, what is the difference between the Imports(as % of merchandise exports) in High income: nonOECD and Imports(as % of merchandise exports) in Korea (Republic)?
Offer a terse response. -2.74. In the year 1996, what is the difference between the Imports(as % of merchandise exports) of High income: nonOECD and Imports(as % of merchandise exports) of Mali?
Your answer should be compact. 1.58. In the year 1996, what is the difference between the Imports(as % of merchandise exports) of High income: nonOECD and Imports(as % of merchandise exports) of Syrian Arab Republic?
Provide a short and direct response. 1.2. In the year 1996, what is the difference between the Imports(as % of merchandise exports) of Korea (Republic) and Imports(as % of merchandise exports) of Mali?
Ensure brevity in your answer.  4.33. In the year 1996, what is the difference between the Imports(as % of merchandise exports) in Korea (Republic) and Imports(as % of merchandise exports) in Syrian Arab Republic?
Provide a short and direct response. 3.95. In the year 1996, what is the difference between the Imports(as % of merchandise exports) of Mali and Imports(as % of merchandise exports) of Syrian Arab Republic?
Your response must be concise. -0.38. In the year 1997, what is the difference between the Imports(as % of merchandise exports) in High income: nonOECD and Imports(as % of merchandise exports) in Korea (Republic)?
Ensure brevity in your answer.  -3.43. In the year 1997, what is the difference between the Imports(as % of merchandise exports) in High income: nonOECD and Imports(as % of merchandise exports) in Mali?
Ensure brevity in your answer.  2.03. In the year 1997, what is the difference between the Imports(as % of merchandise exports) of High income: nonOECD and Imports(as % of merchandise exports) of Syrian Arab Republic?
Your response must be concise. 0.12. In the year 1997, what is the difference between the Imports(as % of merchandise exports) in Korea (Republic) and Imports(as % of merchandise exports) in Mali?
Give a very brief answer. 5.47. In the year 1997, what is the difference between the Imports(as % of merchandise exports) of Korea (Republic) and Imports(as % of merchandise exports) of Syrian Arab Republic?
Provide a succinct answer. 3.55. In the year 1997, what is the difference between the Imports(as % of merchandise exports) in Mali and Imports(as % of merchandise exports) in Syrian Arab Republic?
Give a very brief answer. -1.92. In the year 1998, what is the difference between the Imports(as % of merchandise exports) of High income: nonOECD and Imports(as % of merchandise exports) of Korea (Republic)?
Ensure brevity in your answer.  -4.62. In the year 1998, what is the difference between the Imports(as % of merchandise exports) in High income: nonOECD and Imports(as % of merchandise exports) in Mali?
Make the answer very short. 1.87. In the year 1998, what is the difference between the Imports(as % of merchandise exports) of High income: nonOECD and Imports(as % of merchandise exports) of Syrian Arab Republic?
Offer a terse response. 1.21. In the year 1998, what is the difference between the Imports(as % of merchandise exports) of Korea (Republic) and Imports(as % of merchandise exports) of Mali?
Your answer should be compact. 6.48. In the year 1998, what is the difference between the Imports(as % of merchandise exports) of Korea (Republic) and Imports(as % of merchandise exports) of Syrian Arab Republic?
Ensure brevity in your answer.  5.83. In the year 1998, what is the difference between the Imports(as % of merchandise exports) of Mali and Imports(as % of merchandise exports) of Syrian Arab Republic?
Offer a very short reply. -0.66. In the year 1999, what is the difference between the Imports(as % of merchandise exports) of High income: nonOECD and Imports(as % of merchandise exports) of Korea (Republic)?
Ensure brevity in your answer.  -4.23. In the year 1999, what is the difference between the Imports(as % of merchandise exports) in High income: nonOECD and Imports(as % of merchandise exports) in Mali?
Offer a very short reply. 1.51. In the year 1999, what is the difference between the Imports(as % of merchandise exports) of Korea (Republic) and Imports(as % of merchandise exports) of Mali?
Ensure brevity in your answer.  5.75. In the year 1999, what is the difference between the Imports(as % of merchandise exports) of Korea (Republic) and Imports(as % of merchandise exports) of Syrian Arab Republic?
Make the answer very short. 5.23. In the year 1999, what is the difference between the Imports(as % of merchandise exports) in Mali and Imports(as % of merchandise exports) in Syrian Arab Republic?
Your answer should be very brief. -0.51. In the year 2000, what is the difference between the Imports(as % of merchandise exports) in High income: nonOECD and Imports(as % of merchandise exports) in Korea (Republic)?
Keep it short and to the point. -3.19. In the year 2000, what is the difference between the Imports(as % of merchandise exports) in High income: nonOECD and Imports(as % of merchandise exports) in Mali?
Your response must be concise. 1.81. In the year 2000, what is the difference between the Imports(as % of merchandise exports) of High income: nonOECD and Imports(as % of merchandise exports) of Syrian Arab Republic?
Make the answer very short. 0.69. In the year 2000, what is the difference between the Imports(as % of merchandise exports) in Korea (Republic) and Imports(as % of merchandise exports) in Mali?
Ensure brevity in your answer.  5. In the year 2000, what is the difference between the Imports(as % of merchandise exports) of Korea (Republic) and Imports(as % of merchandise exports) of Syrian Arab Republic?
Provide a succinct answer. 3.87. In the year 2000, what is the difference between the Imports(as % of merchandise exports) of Mali and Imports(as % of merchandise exports) of Syrian Arab Republic?
Provide a short and direct response. -1.13. In the year 2001, what is the difference between the Imports(as % of merchandise exports) of High income: nonOECD and Imports(as % of merchandise exports) of Korea (Republic)?
Offer a very short reply. -3.51. In the year 2001, what is the difference between the Imports(as % of merchandise exports) in High income: nonOECD and Imports(as % of merchandise exports) in Mali?
Give a very brief answer. 1.73. In the year 2001, what is the difference between the Imports(as % of merchandise exports) of High income: nonOECD and Imports(as % of merchandise exports) of Syrian Arab Republic?
Offer a terse response. 1.06. In the year 2001, what is the difference between the Imports(as % of merchandise exports) of Korea (Republic) and Imports(as % of merchandise exports) of Mali?
Your answer should be very brief. 5.24. In the year 2001, what is the difference between the Imports(as % of merchandise exports) of Korea (Republic) and Imports(as % of merchandise exports) of Syrian Arab Republic?
Provide a short and direct response. 4.57. In the year 2001, what is the difference between the Imports(as % of merchandise exports) in Mali and Imports(as % of merchandise exports) in Syrian Arab Republic?
Provide a short and direct response. -0.67. In the year 2002, what is the difference between the Imports(as % of merchandise exports) of High income: nonOECD and Imports(as % of merchandise exports) of Korea (Republic)?
Your response must be concise. -3.17. In the year 2002, what is the difference between the Imports(as % of merchandise exports) of High income: nonOECD and Imports(as % of merchandise exports) of Mali?
Keep it short and to the point. 1.54. In the year 2002, what is the difference between the Imports(as % of merchandise exports) in High income: nonOECD and Imports(as % of merchandise exports) in Syrian Arab Republic?
Offer a terse response. -0.29. In the year 2002, what is the difference between the Imports(as % of merchandise exports) in Korea (Republic) and Imports(as % of merchandise exports) in Mali?
Make the answer very short. 4.71. In the year 2002, what is the difference between the Imports(as % of merchandise exports) in Korea (Republic) and Imports(as % of merchandise exports) in Syrian Arab Republic?
Make the answer very short. 2.88. In the year 2002, what is the difference between the Imports(as % of merchandise exports) of Mali and Imports(as % of merchandise exports) of Syrian Arab Republic?
Your answer should be very brief. -1.83. What is the ratio of the Imports(as % of merchandise exports) of High income: nonOECD in 1996 to that in 1997?
Give a very brief answer. 0.99. What is the ratio of the Imports(as % of merchandise exports) in Korea (Republic) in 1996 to that in 1997?
Your answer should be very brief. 0.88. What is the ratio of the Imports(as % of merchandise exports) of Mali in 1996 to that in 1997?
Keep it short and to the point. 1.68. What is the ratio of the Imports(as % of merchandise exports) in Syrian Arab Republic in 1996 to that in 1997?
Keep it short and to the point. 0.56. What is the ratio of the Imports(as % of merchandise exports) of High income: nonOECD in 1996 to that in 1998?
Make the answer very short. 1.03. What is the ratio of the Imports(as % of merchandise exports) in Mali in 1996 to that in 1998?
Make the answer very short. 1.53. What is the ratio of the Imports(as % of merchandise exports) of Syrian Arab Republic in 1996 to that in 1998?
Provide a short and direct response. 1.06. What is the ratio of the Imports(as % of merchandise exports) of High income: nonOECD in 1996 to that in 1999?
Ensure brevity in your answer.  1.16. What is the ratio of the Imports(as % of merchandise exports) in Korea (Republic) in 1996 to that in 1999?
Provide a succinct answer. 0.83. What is the ratio of the Imports(as % of merchandise exports) of Mali in 1996 to that in 1999?
Keep it short and to the point. 1.39. What is the ratio of the Imports(as % of merchandise exports) of Syrian Arab Republic in 1996 to that in 1999?
Keep it short and to the point. 1.13. What is the ratio of the Imports(as % of merchandise exports) in High income: nonOECD in 1996 to that in 2000?
Keep it short and to the point. 1.06. What is the ratio of the Imports(as % of merchandise exports) in Korea (Republic) in 1996 to that in 2000?
Provide a succinct answer. 0.95. What is the ratio of the Imports(as % of merchandise exports) of Mali in 1996 to that in 2000?
Provide a short and direct response. 1.56. What is the ratio of the Imports(as % of merchandise exports) of Syrian Arab Republic in 1996 to that in 2000?
Offer a terse response. 0.79. What is the ratio of the Imports(as % of merchandise exports) of High income: nonOECD in 1996 to that in 2001?
Make the answer very short. 1.13. What is the ratio of the Imports(as % of merchandise exports) of Korea (Republic) in 1996 to that in 2001?
Ensure brevity in your answer.  0.92. What is the ratio of the Imports(as % of merchandise exports) of Mali in 1996 to that in 2001?
Make the answer very short. 1.72. What is the ratio of the Imports(as % of merchandise exports) of Syrian Arab Republic in 1996 to that in 2001?
Make the answer very short. 1.12. What is the ratio of the Imports(as % of merchandise exports) of High income: nonOECD in 1996 to that in 2002?
Provide a short and direct response. 1.1. What is the ratio of the Imports(as % of merchandise exports) of Korea (Republic) in 1996 to that in 2002?
Offer a very short reply. 0.97. What is the ratio of the Imports(as % of merchandise exports) in Mali in 1996 to that in 2002?
Offer a very short reply. 1.22. What is the ratio of the Imports(as % of merchandise exports) of Syrian Arab Republic in 1996 to that in 2002?
Offer a terse response. 0.53. What is the ratio of the Imports(as % of merchandise exports) of High income: nonOECD in 1997 to that in 1998?
Offer a very short reply. 1.04. What is the ratio of the Imports(as % of merchandise exports) in Korea (Republic) in 1997 to that in 1998?
Your response must be concise. 0.85. What is the ratio of the Imports(as % of merchandise exports) in Mali in 1997 to that in 1998?
Give a very brief answer. 0.91. What is the ratio of the Imports(as % of merchandise exports) of Syrian Arab Republic in 1997 to that in 1998?
Keep it short and to the point. 1.89. What is the ratio of the Imports(as % of merchandise exports) in High income: nonOECD in 1997 to that in 1999?
Provide a short and direct response. 1.17. What is the ratio of the Imports(as % of merchandise exports) of Korea (Republic) in 1997 to that in 1999?
Offer a very short reply. 0.94. What is the ratio of the Imports(as % of merchandise exports) of Mali in 1997 to that in 1999?
Your answer should be compact. 0.83. What is the ratio of the Imports(as % of merchandise exports) in Syrian Arab Republic in 1997 to that in 1999?
Provide a short and direct response. 2. What is the ratio of the Imports(as % of merchandise exports) in High income: nonOECD in 1997 to that in 2000?
Your answer should be very brief. 1.07. What is the ratio of the Imports(as % of merchandise exports) of Korea (Republic) in 1997 to that in 2000?
Your answer should be compact. 1.07. What is the ratio of the Imports(as % of merchandise exports) of Mali in 1997 to that in 2000?
Provide a short and direct response. 0.93. What is the ratio of the Imports(as % of merchandise exports) of Syrian Arab Republic in 1997 to that in 2000?
Give a very brief answer. 1.41. What is the ratio of the Imports(as % of merchandise exports) of High income: nonOECD in 1997 to that in 2001?
Offer a very short reply. 1.14. What is the ratio of the Imports(as % of merchandise exports) of Korea (Republic) in 1997 to that in 2001?
Your answer should be very brief. 1.04. What is the ratio of the Imports(as % of merchandise exports) of Mali in 1997 to that in 2001?
Make the answer very short. 1.03. What is the ratio of the Imports(as % of merchandise exports) of Syrian Arab Republic in 1997 to that in 2001?
Offer a very short reply. 1.99. What is the ratio of the Imports(as % of merchandise exports) in High income: nonOECD in 1997 to that in 2002?
Give a very brief answer. 1.11. What is the ratio of the Imports(as % of merchandise exports) in Korea (Republic) in 1997 to that in 2002?
Keep it short and to the point. 1.1. What is the ratio of the Imports(as % of merchandise exports) in Mali in 1997 to that in 2002?
Offer a terse response. 0.73. What is the ratio of the Imports(as % of merchandise exports) of Syrian Arab Republic in 1997 to that in 2002?
Keep it short and to the point. 0.95. What is the ratio of the Imports(as % of merchandise exports) of High income: nonOECD in 1998 to that in 1999?
Your answer should be compact. 1.12. What is the ratio of the Imports(as % of merchandise exports) in Korea (Republic) in 1998 to that in 1999?
Make the answer very short. 1.1. What is the ratio of the Imports(as % of merchandise exports) in Mali in 1998 to that in 1999?
Provide a short and direct response. 0.91. What is the ratio of the Imports(as % of merchandise exports) of Syrian Arab Republic in 1998 to that in 1999?
Offer a very short reply. 1.06. What is the ratio of the Imports(as % of merchandise exports) of High income: nonOECD in 1998 to that in 2000?
Give a very brief answer. 1.03. What is the ratio of the Imports(as % of merchandise exports) of Korea (Republic) in 1998 to that in 2000?
Your response must be concise. 1.26. What is the ratio of the Imports(as % of merchandise exports) in Mali in 1998 to that in 2000?
Ensure brevity in your answer.  1.02. What is the ratio of the Imports(as % of merchandise exports) of Syrian Arab Republic in 1998 to that in 2000?
Give a very brief answer. 0.75. What is the ratio of the Imports(as % of merchandise exports) of High income: nonOECD in 1998 to that in 2001?
Your answer should be very brief. 1.09. What is the ratio of the Imports(as % of merchandise exports) of Korea (Republic) in 1998 to that in 2001?
Your response must be concise. 1.23. What is the ratio of the Imports(as % of merchandise exports) in Mali in 1998 to that in 2001?
Your answer should be compact. 1.13. What is the ratio of the Imports(as % of merchandise exports) of Syrian Arab Republic in 1998 to that in 2001?
Ensure brevity in your answer.  1.05. What is the ratio of the Imports(as % of merchandise exports) of High income: nonOECD in 1998 to that in 2002?
Your response must be concise. 1.07. What is the ratio of the Imports(as % of merchandise exports) of Korea (Republic) in 1998 to that in 2002?
Give a very brief answer. 1.29. What is the ratio of the Imports(as % of merchandise exports) in Mali in 1998 to that in 2002?
Your response must be concise. 0.8. What is the ratio of the Imports(as % of merchandise exports) of Syrian Arab Republic in 1998 to that in 2002?
Ensure brevity in your answer.  0.5. What is the ratio of the Imports(as % of merchandise exports) of High income: nonOECD in 1999 to that in 2000?
Make the answer very short. 0.91. What is the ratio of the Imports(as % of merchandise exports) of Korea (Republic) in 1999 to that in 2000?
Provide a short and direct response. 1.15. What is the ratio of the Imports(as % of merchandise exports) in Mali in 1999 to that in 2000?
Give a very brief answer. 1.13. What is the ratio of the Imports(as % of merchandise exports) in Syrian Arab Republic in 1999 to that in 2000?
Ensure brevity in your answer.  0.7. What is the ratio of the Imports(as % of merchandise exports) of High income: nonOECD in 1999 to that in 2001?
Ensure brevity in your answer.  0.97. What is the ratio of the Imports(as % of merchandise exports) of Korea (Republic) in 1999 to that in 2001?
Keep it short and to the point. 1.11. What is the ratio of the Imports(as % of merchandise exports) in Mali in 1999 to that in 2001?
Your answer should be compact. 1.24. What is the ratio of the Imports(as % of merchandise exports) of High income: nonOECD in 1999 to that in 2002?
Ensure brevity in your answer.  0.95. What is the ratio of the Imports(as % of merchandise exports) of Korea (Republic) in 1999 to that in 2002?
Give a very brief answer. 1.17. What is the ratio of the Imports(as % of merchandise exports) in Mali in 1999 to that in 2002?
Provide a short and direct response. 0.88. What is the ratio of the Imports(as % of merchandise exports) in Syrian Arab Republic in 1999 to that in 2002?
Your response must be concise. 0.47. What is the ratio of the Imports(as % of merchandise exports) of High income: nonOECD in 2000 to that in 2001?
Provide a short and direct response. 1.06. What is the ratio of the Imports(as % of merchandise exports) in Korea (Republic) in 2000 to that in 2001?
Ensure brevity in your answer.  0.97. What is the ratio of the Imports(as % of merchandise exports) in Mali in 2000 to that in 2001?
Provide a succinct answer. 1.1. What is the ratio of the Imports(as % of merchandise exports) of Syrian Arab Republic in 2000 to that in 2001?
Your answer should be very brief. 1.41. What is the ratio of the Imports(as % of merchandise exports) of High income: nonOECD in 2000 to that in 2002?
Provide a succinct answer. 1.04. What is the ratio of the Imports(as % of merchandise exports) in Korea (Republic) in 2000 to that in 2002?
Provide a succinct answer. 1.02. What is the ratio of the Imports(as % of merchandise exports) in Mali in 2000 to that in 2002?
Offer a very short reply. 0.78. What is the ratio of the Imports(as % of merchandise exports) in Syrian Arab Republic in 2000 to that in 2002?
Your response must be concise. 0.67. What is the ratio of the Imports(as % of merchandise exports) in High income: nonOECD in 2001 to that in 2002?
Make the answer very short. 0.98. What is the ratio of the Imports(as % of merchandise exports) in Korea (Republic) in 2001 to that in 2002?
Give a very brief answer. 1.05. What is the ratio of the Imports(as % of merchandise exports) in Mali in 2001 to that in 2002?
Your answer should be compact. 0.71. What is the ratio of the Imports(as % of merchandise exports) of Syrian Arab Republic in 2001 to that in 2002?
Offer a very short reply. 0.48. What is the difference between the highest and the second highest Imports(as % of merchandise exports) of High income: nonOECD?
Your answer should be compact. 0.02. What is the difference between the highest and the second highest Imports(as % of merchandise exports) in Korea (Republic)?
Your answer should be compact. 0.67. What is the difference between the highest and the second highest Imports(as % of merchandise exports) in Mali?
Your response must be concise. 0.19. What is the difference between the highest and the second highest Imports(as % of merchandise exports) of Syrian Arab Republic?
Keep it short and to the point. 0.14. What is the difference between the highest and the lowest Imports(as % of merchandise exports) of High income: nonOECD?
Offer a very short reply. 0.39. What is the difference between the highest and the lowest Imports(as % of merchandise exports) in Korea (Republic)?
Offer a very short reply. 1.79. What is the difference between the highest and the lowest Imports(as % of merchandise exports) in Mali?
Your response must be concise. 0.44. What is the difference between the highest and the lowest Imports(as % of merchandise exports) of Syrian Arab Republic?
Give a very brief answer. 1.41. 